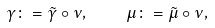<formula> <loc_0><loc_0><loc_500><loc_500>\gamma \colon = \tilde { \gamma } \circ \nu , \quad \mu \colon = \tilde { \mu } \circ \nu ,</formula> 